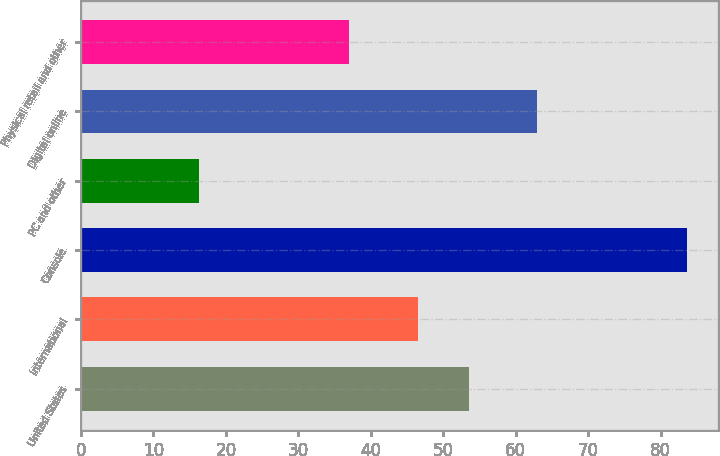<chart> <loc_0><loc_0><loc_500><loc_500><bar_chart><fcel>United States<fcel>International<fcel>Console<fcel>PC and other<fcel>Digital online<fcel>Physical retail and other<nl><fcel>53.5<fcel>46.5<fcel>83.7<fcel>16.3<fcel>63<fcel>37<nl></chart> 